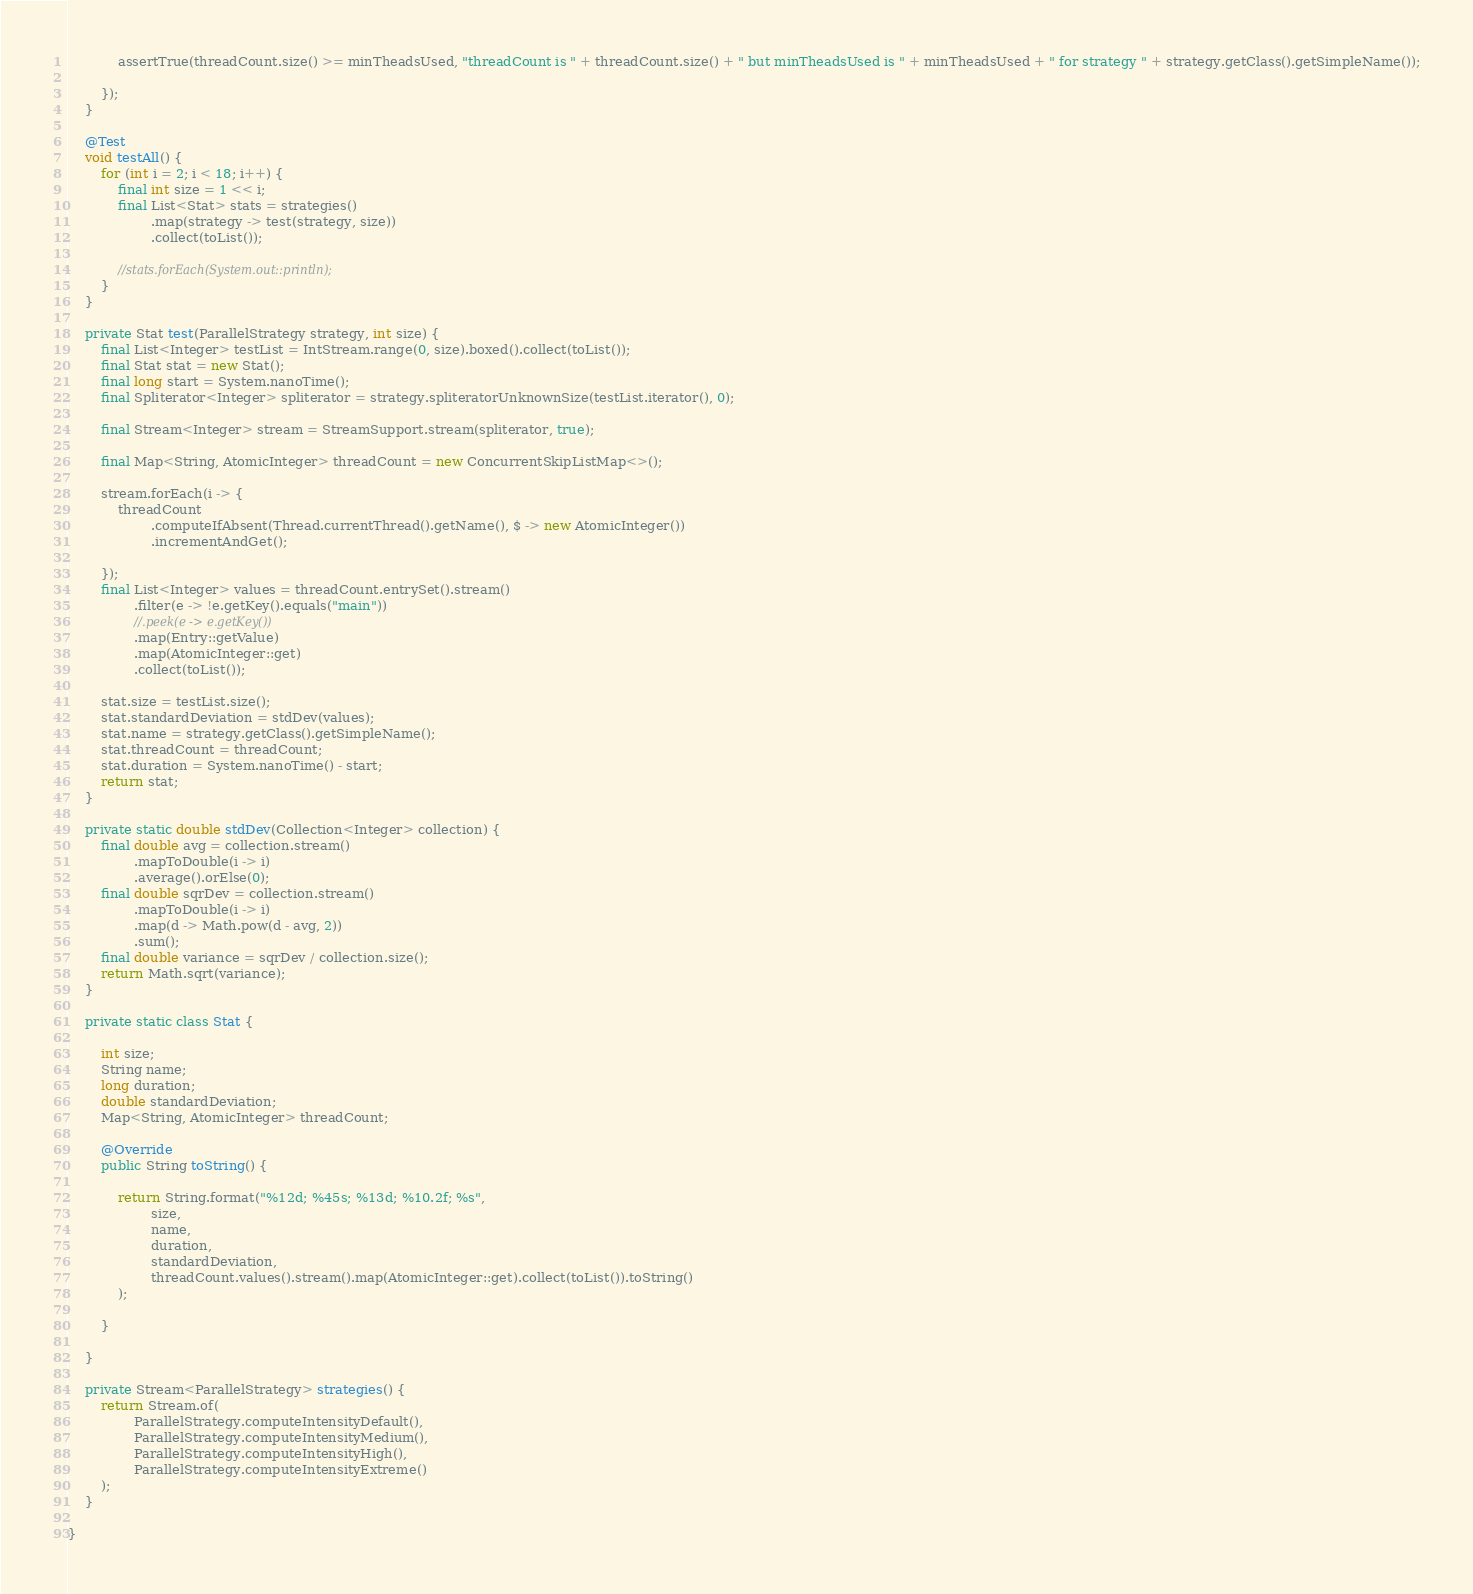Convert code to text. <code><loc_0><loc_0><loc_500><loc_500><_Java_>            assertTrue(threadCount.size() >= minTheadsUsed, "threadCount is " + threadCount.size() + " but minTheadsUsed is " + minTheadsUsed + " for strategy " + strategy.getClass().getSimpleName());

        });
    }

    @Test
    void testAll() {
        for (int i = 2; i < 18; i++) {
            final int size = 1 << i;
            final List<Stat> stats = strategies()
                    .map(strategy -> test(strategy, size))
                    .collect(toList());

            //stats.forEach(System.out::println);
        }
    }

    private Stat test(ParallelStrategy strategy, int size) {
        final List<Integer> testList = IntStream.range(0, size).boxed().collect(toList());
        final Stat stat = new Stat();
        final long start = System.nanoTime();
        final Spliterator<Integer> spliterator = strategy.spliteratorUnknownSize(testList.iterator(), 0);

        final Stream<Integer> stream = StreamSupport.stream(spliterator, true);

        final Map<String, AtomicInteger> threadCount = new ConcurrentSkipListMap<>();

        stream.forEach(i -> {
            threadCount
                    .computeIfAbsent(Thread.currentThread().getName(), $ -> new AtomicInteger())
                    .incrementAndGet();

        });
        final List<Integer> values = threadCount.entrySet().stream()
                .filter(e -> !e.getKey().equals("main"))
                //.peek(e -> e.getKey())
                .map(Entry::getValue)
                .map(AtomicInteger::get)
                .collect(toList());

        stat.size = testList.size();
        stat.standardDeviation = stdDev(values);
        stat.name = strategy.getClass().getSimpleName();
        stat.threadCount = threadCount;
        stat.duration = System.nanoTime() - start;
        return stat;
    }

    private static double stdDev(Collection<Integer> collection) {
        final double avg = collection.stream()
                .mapToDouble(i -> i)
                .average().orElse(0);
        final double sqrDev = collection.stream()
                .mapToDouble(i -> i)
                .map(d -> Math.pow(d - avg, 2))
                .sum();
        final double variance = sqrDev / collection.size();
        return Math.sqrt(variance);
    }

    private static class Stat {

        int size;
        String name;
        long duration;
        double standardDeviation;
        Map<String, AtomicInteger> threadCount;

        @Override
        public String toString() {

            return String.format("%12d; %45s; %13d; %10.2f; %s",
                    size,
                    name,
                    duration,
                    standardDeviation,
                    threadCount.values().stream().map(AtomicInteger::get).collect(toList()).toString()
            );

        }

    }

    private Stream<ParallelStrategy> strategies() {
        return Stream.of(
                ParallelStrategy.computeIntensityDefault(),
                ParallelStrategy.computeIntensityMedium(),
                ParallelStrategy.computeIntensityHigh(),
                ParallelStrategy.computeIntensityExtreme()
        );
    }

}
</code> 